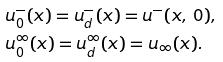Convert formula to latex. <formula><loc_0><loc_0><loc_500><loc_500>& u _ { 0 } ^ { - } ( x ) = u _ { d } ^ { - } ( x ) = u ^ { - } ( x , \, 0 ) , \\ & u _ { 0 } ^ { \infty } ( x ) = u _ { d } ^ { \infty } ( x ) = u _ { \infty } ( x ) .</formula> 